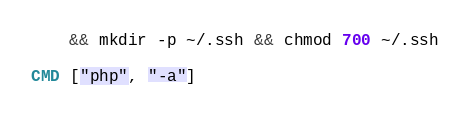Convert code to text. <code><loc_0><loc_0><loc_500><loc_500><_Dockerfile_>    && mkdir -p ~/.ssh && chmod 700 ~/.ssh

CMD ["php", "-a"]
</code> 